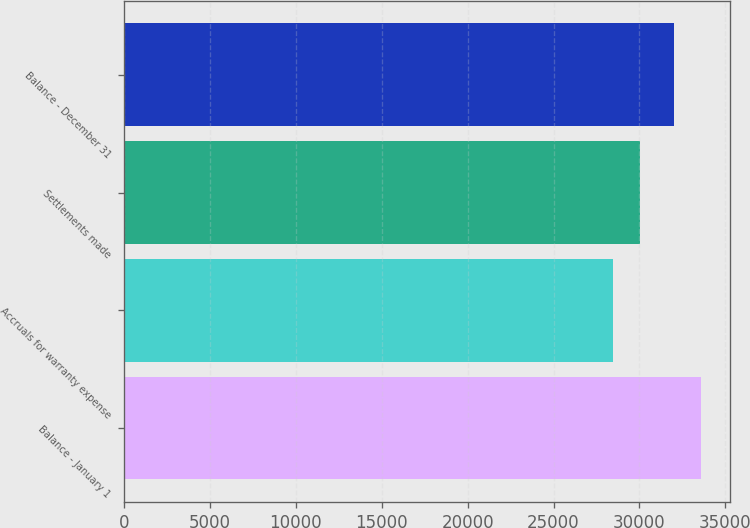Convert chart. <chart><loc_0><loc_0><loc_500><loc_500><bar_chart><fcel>Balance - January 1<fcel>Accruals for warranty expense<fcel>Settlements made<fcel>Balance - December 31<nl><fcel>33601<fcel>28454<fcel>30022<fcel>32033<nl></chart> 